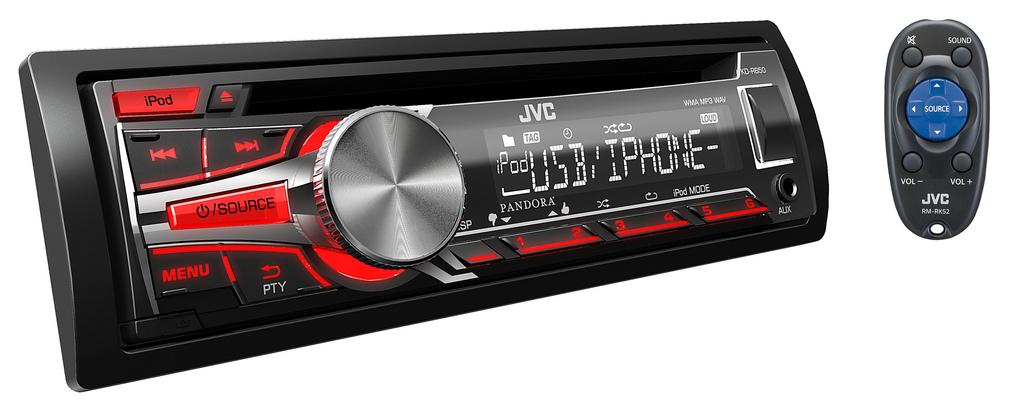<image>
Give a short and clear explanation of the subsequent image. Faceplate and remote for a JVC brand car stereo. 